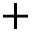<formula> <loc_0><loc_0><loc_500><loc_500>+</formula> 